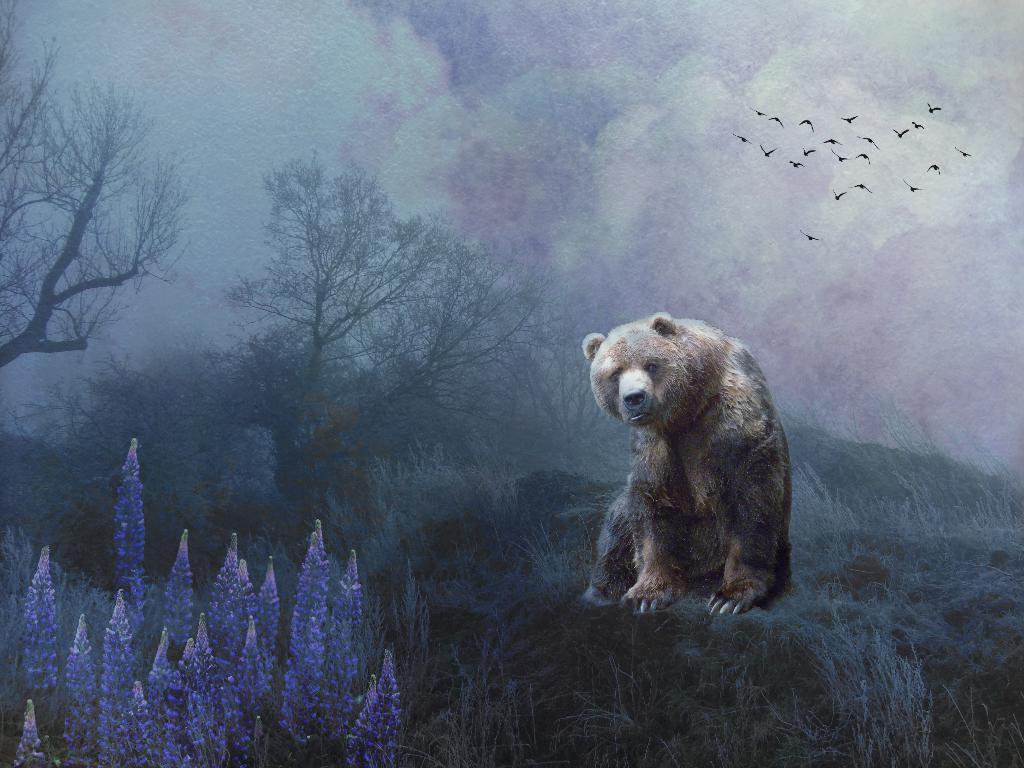How would you summarize this image in a sentence or two? In this edited picture there is a bear sitting on the grassland sitting on the grassland having few plants and trees. Left bottom there are few plants having flowers. Top of the image there is sky. Few birds are flying in the air. 